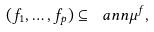<formula> <loc_0><loc_0><loc_500><loc_500>( f _ { 1 } , \dots , f _ { p } ) \subseteq \ a n n \mu ^ { f } ,</formula> 